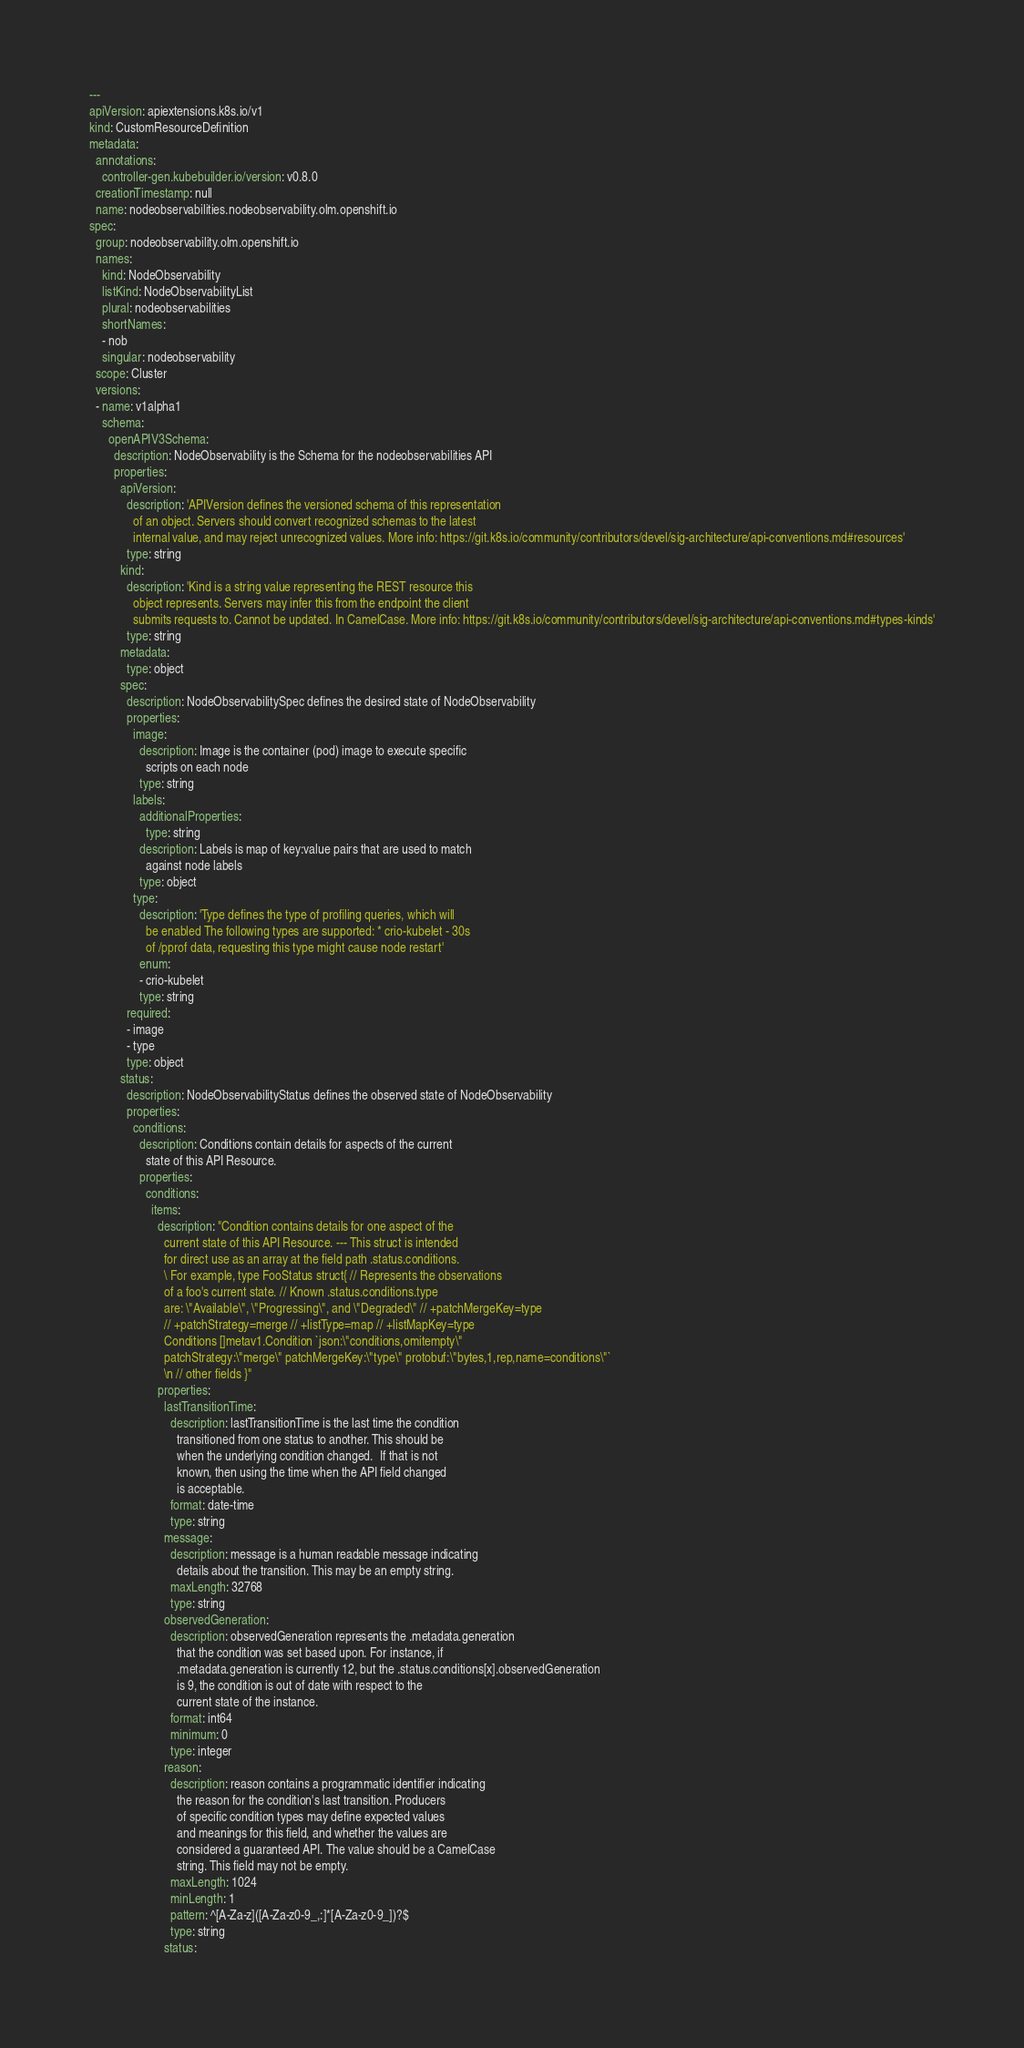Convert code to text. <code><loc_0><loc_0><loc_500><loc_500><_YAML_>---
apiVersion: apiextensions.k8s.io/v1
kind: CustomResourceDefinition
metadata:
  annotations:
    controller-gen.kubebuilder.io/version: v0.8.0
  creationTimestamp: null
  name: nodeobservabilities.nodeobservability.olm.openshift.io
spec:
  group: nodeobservability.olm.openshift.io
  names:
    kind: NodeObservability
    listKind: NodeObservabilityList
    plural: nodeobservabilities
    shortNames:
    - nob
    singular: nodeobservability
  scope: Cluster
  versions:
  - name: v1alpha1
    schema:
      openAPIV3Schema:
        description: NodeObservability is the Schema for the nodeobservabilities API
        properties:
          apiVersion:
            description: 'APIVersion defines the versioned schema of this representation
              of an object. Servers should convert recognized schemas to the latest
              internal value, and may reject unrecognized values. More info: https://git.k8s.io/community/contributors/devel/sig-architecture/api-conventions.md#resources'
            type: string
          kind:
            description: 'Kind is a string value representing the REST resource this
              object represents. Servers may infer this from the endpoint the client
              submits requests to. Cannot be updated. In CamelCase. More info: https://git.k8s.io/community/contributors/devel/sig-architecture/api-conventions.md#types-kinds'
            type: string
          metadata:
            type: object
          spec:
            description: NodeObservabilitySpec defines the desired state of NodeObservability
            properties:
              image:
                description: Image is the container (pod) image to execute specific
                  scripts on each node
                type: string
              labels:
                additionalProperties:
                  type: string
                description: Labels is map of key:value pairs that are used to match
                  against node labels
                type: object
              type:
                description: 'Type defines the type of profiling queries, which will
                  be enabled The following types are supported: * crio-kubelet - 30s
                  of /pprof data, requesting this type might cause node restart'
                enum:
                - crio-kubelet
                type: string
            required:
            - image
            - type
            type: object
          status:
            description: NodeObservabilityStatus defines the observed state of NodeObservability
            properties:
              conditions:
                description: Conditions contain details for aspects of the current
                  state of this API Resource.
                properties:
                  conditions:
                    items:
                      description: "Condition contains details for one aspect of the
                        current state of this API Resource. --- This struct is intended
                        for direct use as an array at the field path .status.conditions.
                        \ For example, type FooStatus struct{ // Represents the observations
                        of a foo's current state. // Known .status.conditions.type
                        are: \"Available\", \"Progressing\", and \"Degraded\" // +patchMergeKey=type
                        // +patchStrategy=merge // +listType=map // +listMapKey=type
                        Conditions []metav1.Condition `json:\"conditions,omitempty\"
                        patchStrategy:\"merge\" patchMergeKey:\"type\" protobuf:\"bytes,1,rep,name=conditions\"`
                        \n // other fields }"
                      properties:
                        lastTransitionTime:
                          description: lastTransitionTime is the last time the condition
                            transitioned from one status to another. This should be
                            when the underlying condition changed.  If that is not
                            known, then using the time when the API field changed
                            is acceptable.
                          format: date-time
                          type: string
                        message:
                          description: message is a human readable message indicating
                            details about the transition. This may be an empty string.
                          maxLength: 32768
                          type: string
                        observedGeneration:
                          description: observedGeneration represents the .metadata.generation
                            that the condition was set based upon. For instance, if
                            .metadata.generation is currently 12, but the .status.conditions[x].observedGeneration
                            is 9, the condition is out of date with respect to the
                            current state of the instance.
                          format: int64
                          minimum: 0
                          type: integer
                        reason:
                          description: reason contains a programmatic identifier indicating
                            the reason for the condition's last transition. Producers
                            of specific condition types may define expected values
                            and meanings for this field, and whether the values are
                            considered a guaranteed API. The value should be a CamelCase
                            string. This field may not be empty.
                          maxLength: 1024
                          minLength: 1
                          pattern: ^[A-Za-z]([A-Za-z0-9_,:]*[A-Za-z0-9_])?$
                          type: string
                        status:</code> 